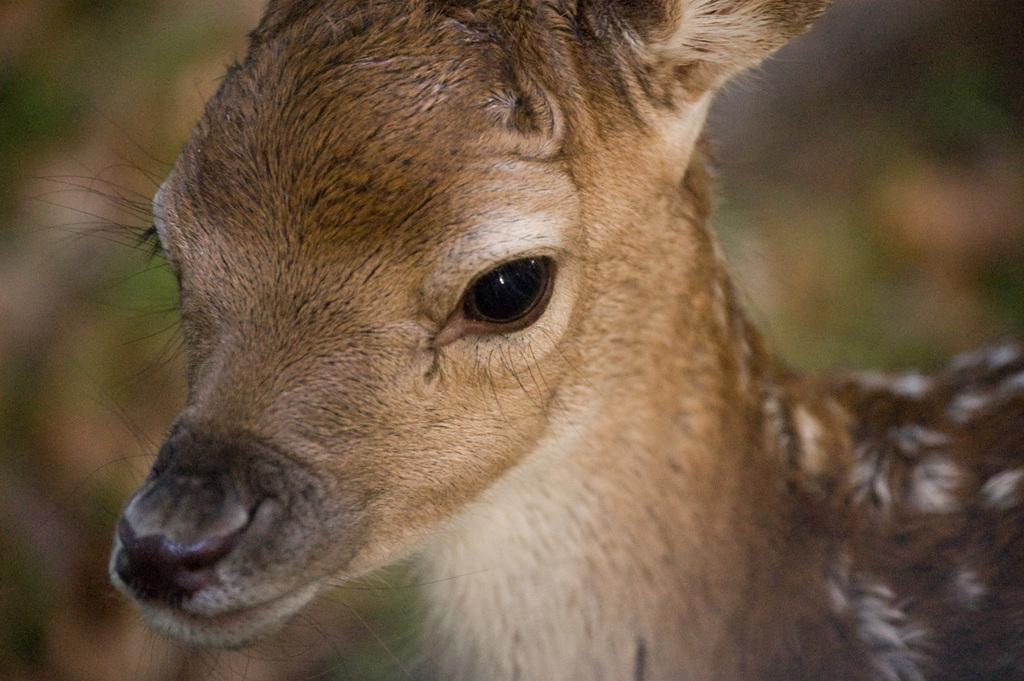In one or two sentences, can you explain what this image depicts? In this picture I can observe a deer in the middle of the picture. The deer is in brown color. The background is completely blurred. 